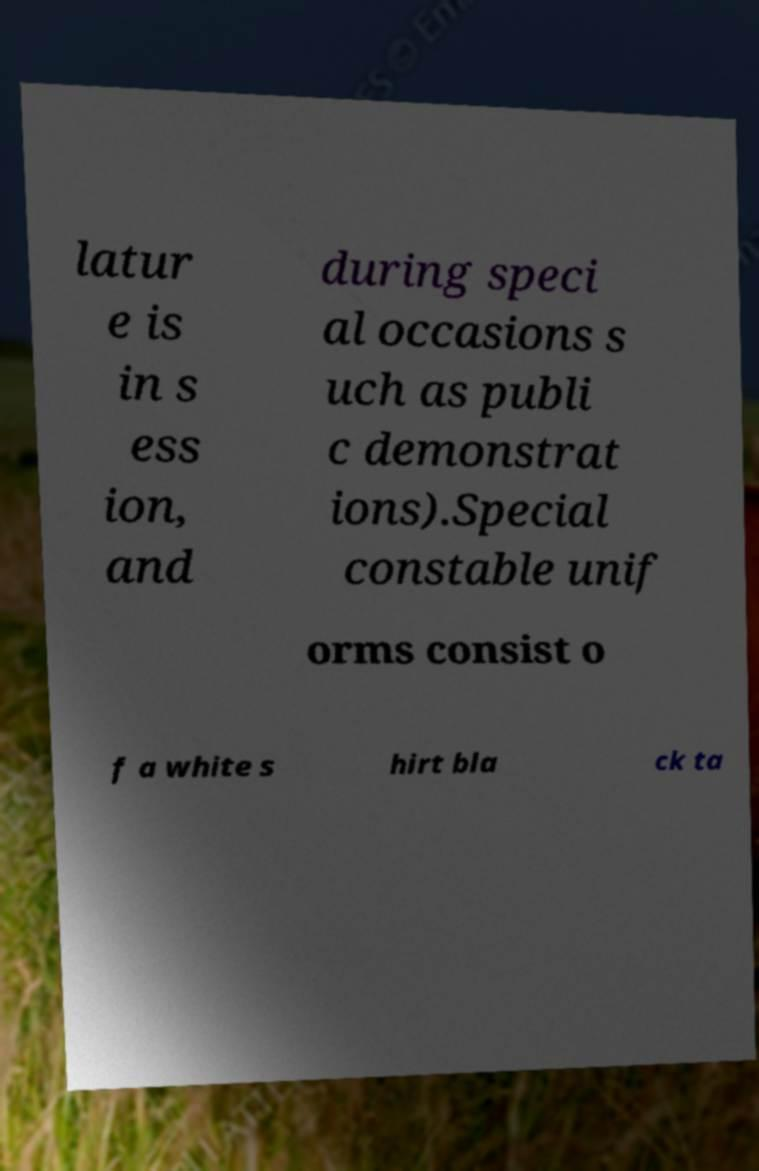Could you extract and type out the text from this image? latur e is in s ess ion, and during speci al occasions s uch as publi c demonstrat ions).Special constable unif orms consist o f a white s hirt bla ck ta 